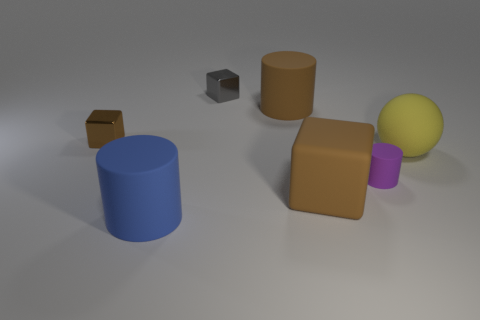Add 2 large rubber cylinders. How many objects exist? 9 Subtract all cubes. How many objects are left? 4 Add 7 big brown rubber things. How many big brown rubber things are left? 9 Add 1 big brown cylinders. How many big brown cylinders exist? 2 Subtract 0 blue blocks. How many objects are left? 7 Subtract all tiny red objects. Subtract all cylinders. How many objects are left? 4 